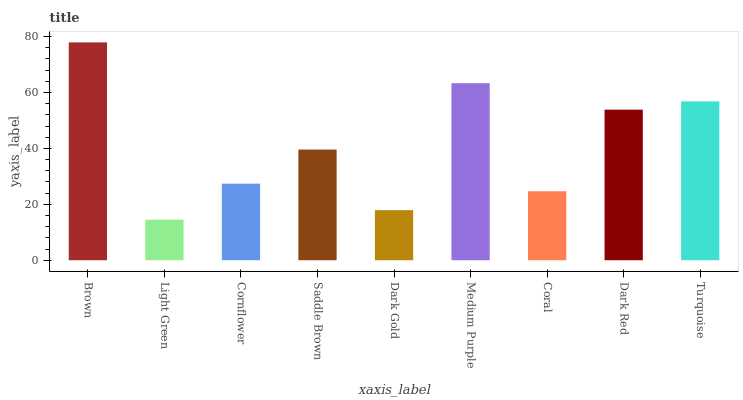Is Light Green the minimum?
Answer yes or no. Yes. Is Brown the maximum?
Answer yes or no. Yes. Is Cornflower the minimum?
Answer yes or no. No. Is Cornflower the maximum?
Answer yes or no. No. Is Cornflower greater than Light Green?
Answer yes or no. Yes. Is Light Green less than Cornflower?
Answer yes or no. Yes. Is Light Green greater than Cornflower?
Answer yes or no. No. Is Cornflower less than Light Green?
Answer yes or no. No. Is Saddle Brown the high median?
Answer yes or no. Yes. Is Saddle Brown the low median?
Answer yes or no. Yes. Is Dark Gold the high median?
Answer yes or no. No. Is Cornflower the low median?
Answer yes or no. No. 